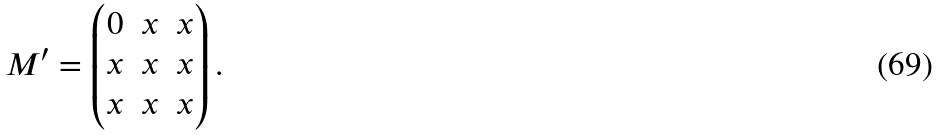Convert formula to latex. <formula><loc_0><loc_0><loc_500><loc_500>M ^ { \prime } = \begin{pmatrix} 0 & x & x \\ x & x & x \\ x & x & x \end{pmatrix} .</formula> 